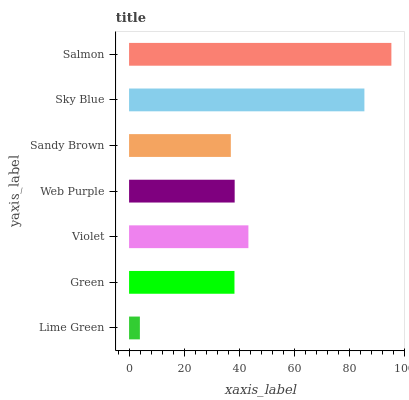Is Lime Green the minimum?
Answer yes or no. Yes. Is Salmon the maximum?
Answer yes or no. Yes. Is Green the minimum?
Answer yes or no. No. Is Green the maximum?
Answer yes or no. No. Is Green greater than Lime Green?
Answer yes or no. Yes. Is Lime Green less than Green?
Answer yes or no. Yes. Is Lime Green greater than Green?
Answer yes or no. No. Is Green less than Lime Green?
Answer yes or no. No. Is Web Purple the high median?
Answer yes or no. Yes. Is Web Purple the low median?
Answer yes or no. Yes. Is Green the high median?
Answer yes or no. No. Is Lime Green the low median?
Answer yes or no. No. 